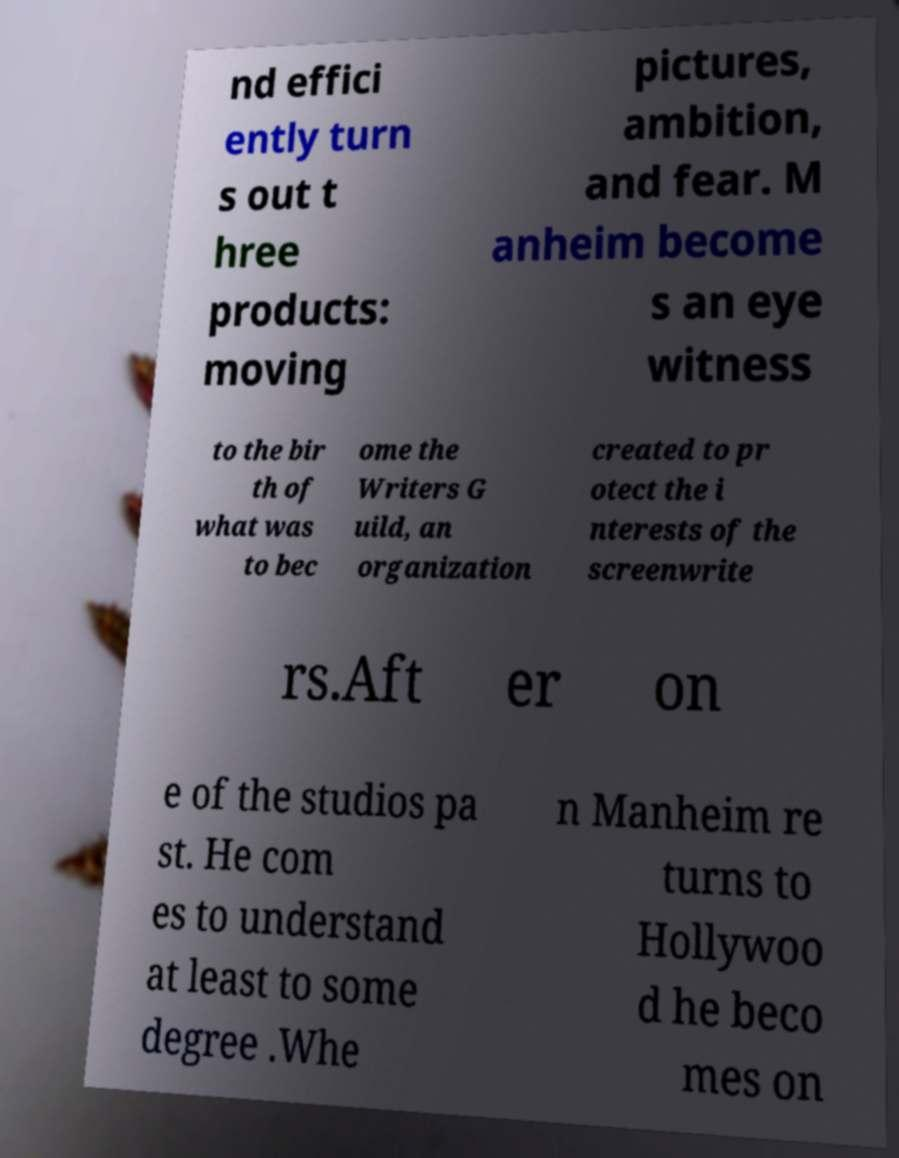Could you extract and type out the text from this image? nd effici ently turn s out t hree products: moving pictures, ambition, and fear. M anheim become s an eye witness to the bir th of what was to bec ome the Writers G uild, an organization created to pr otect the i nterests of the screenwrite rs.Aft er on e of the studios pa st. He com es to understand at least to some degree .Whe n Manheim re turns to Hollywoo d he beco mes on 